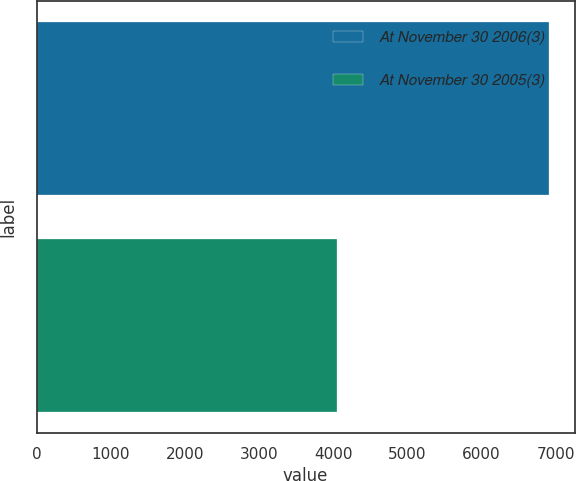Convert chart. <chart><loc_0><loc_0><loc_500><loc_500><bar_chart><fcel>At November 30 2006(3)<fcel>At November 30 2005(3)<nl><fcel>6908<fcel>4046<nl></chart> 